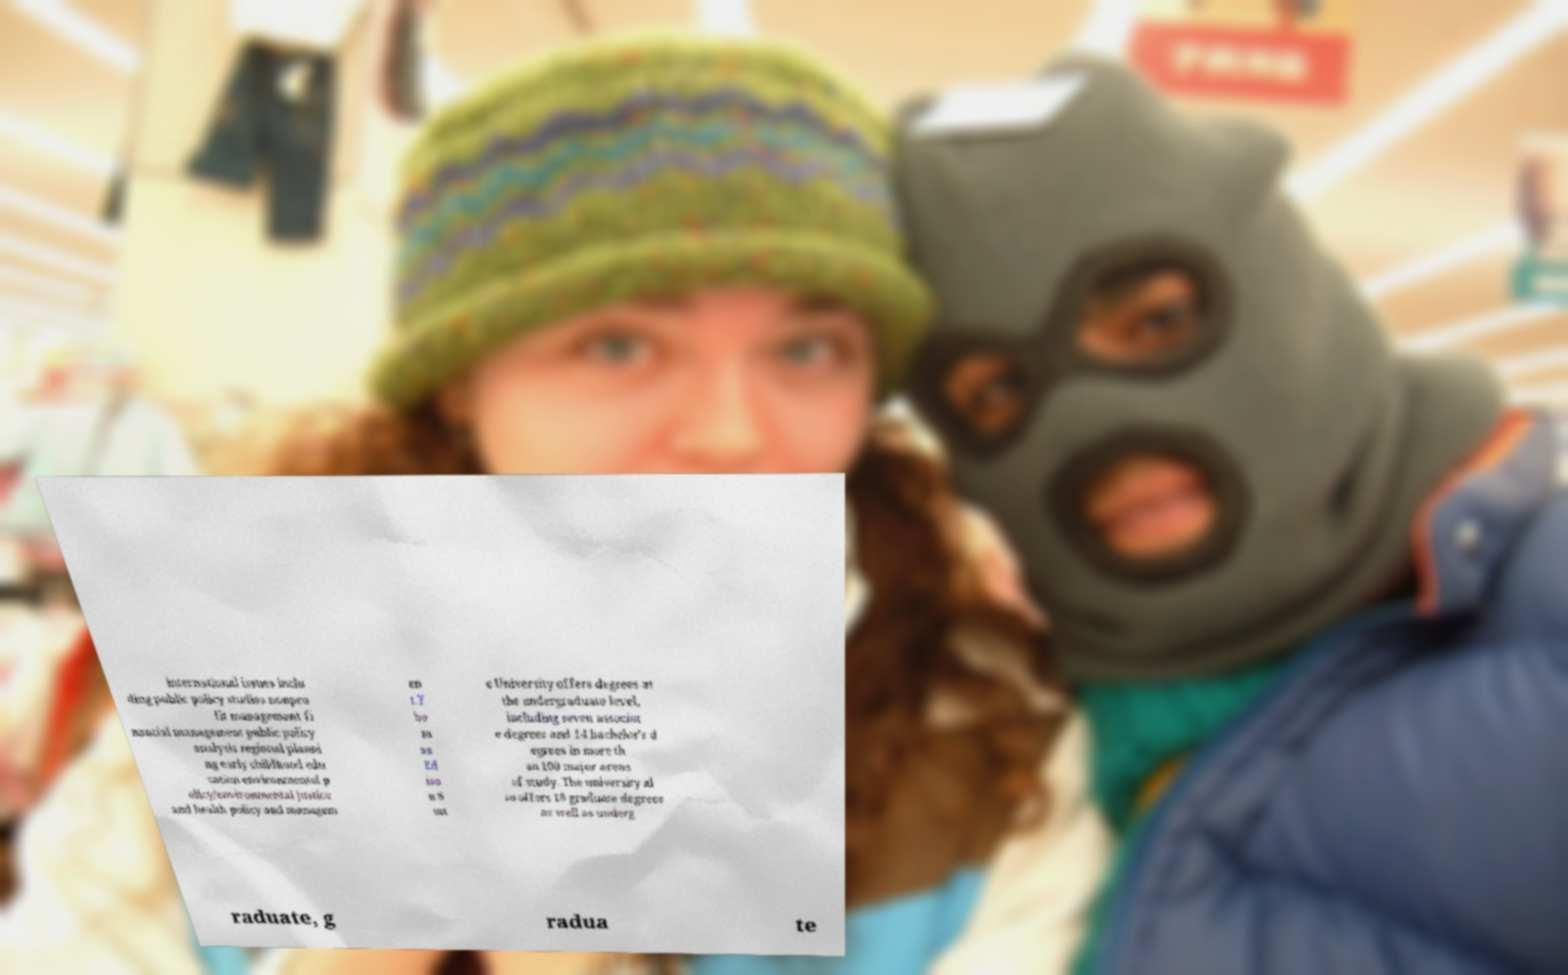Could you assist in decoding the text presented in this image and type it out clearly? international issues inclu ding public policy studies nonpro fit management fi nancial management public policy analysis regional planni ng early childhood edu cation environmental p olicy/environmental justice and health policy and managem en t.T ho m as Ed iso n S tat e University offers degrees at the undergraduate level, including seven associat e degrees and 14 bachelor's d egrees in more th an 100 major areas of study. The university al so offers 18 graduate degrees as well as underg raduate, g radua te 